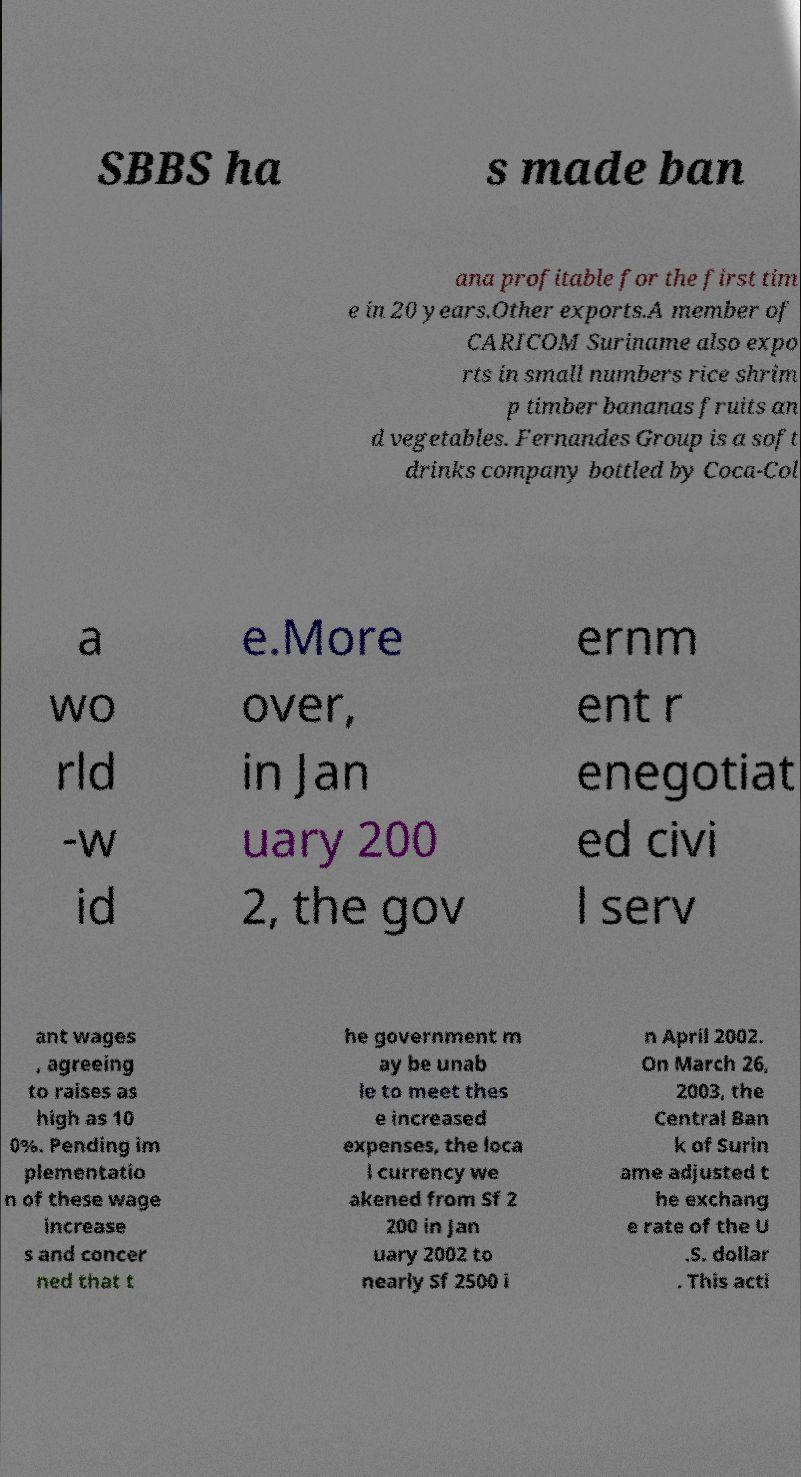There's text embedded in this image that I need extracted. Can you transcribe it verbatim? SBBS ha s made ban ana profitable for the first tim e in 20 years.Other exports.A member of CARICOM Suriname also expo rts in small numbers rice shrim p timber bananas fruits an d vegetables. Fernandes Group is a soft drinks company bottled by Coca-Col a wo rld -w id e.More over, in Jan uary 200 2, the gov ernm ent r enegotiat ed civi l serv ant wages , agreeing to raises as high as 10 0%. Pending im plementatio n of these wage increase s and concer ned that t he government m ay be unab le to meet thes e increased expenses, the loca l currency we akened from Sf 2 200 in Jan uary 2002 to nearly Sf 2500 i n April 2002. On March 26, 2003, the Central Ban k of Surin ame adjusted t he exchang e rate of the U .S. dollar . This acti 